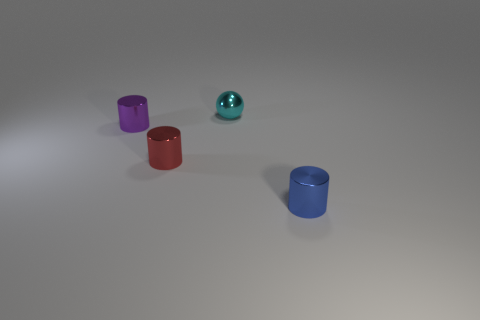Add 1 tiny gray cylinders. How many objects exist? 5 Subtract all cylinders. How many objects are left? 1 Subtract all small red metallic objects. Subtract all cyan balls. How many objects are left? 2 Add 1 blue cylinders. How many blue cylinders are left? 2 Add 2 tiny cyan shiny spheres. How many tiny cyan shiny spheres exist? 3 Subtract 0 yellow cubes. How many objects are left? 4 